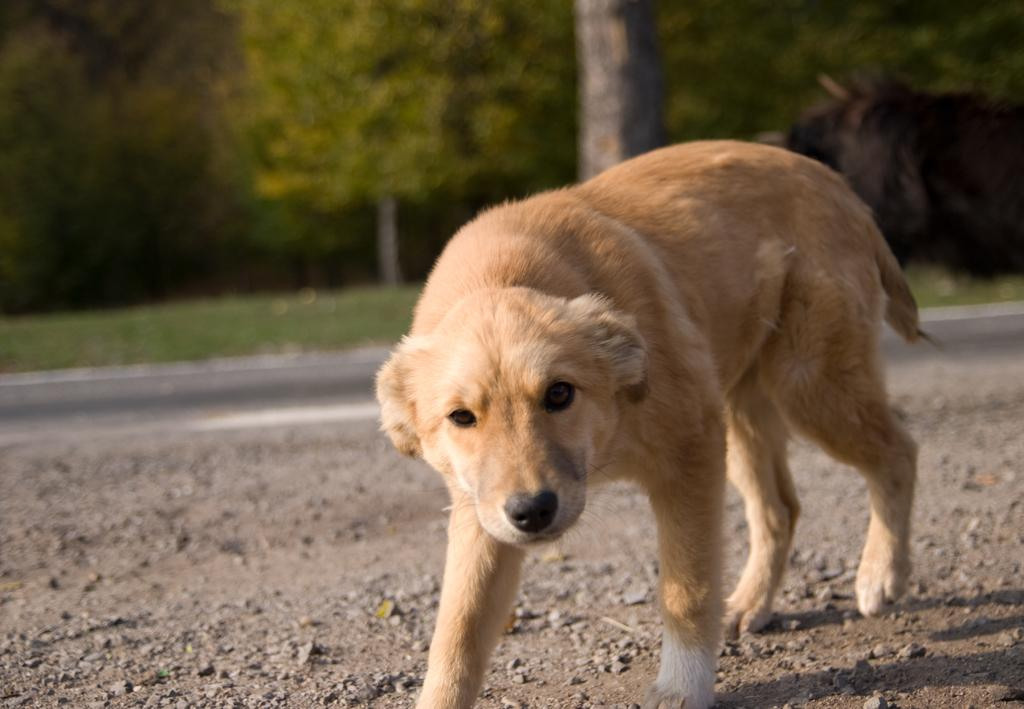What type of animal is in the image? There is a dog in the image. What is behind the dog in the image? There is a road behind the dog. Can you describe any other natural elements in the image? There is a tree trunk visible in the image, and there are trees in the background. What type of net is being used to catch the fish for dinner in the image? There is no net or fish present in the image; it features a dog, a road, a tree trunk, and trees in the background. What joke is being told by the dog in the image? Dogs do not tell jokes, and there is no indication of any joke being told in the image. 